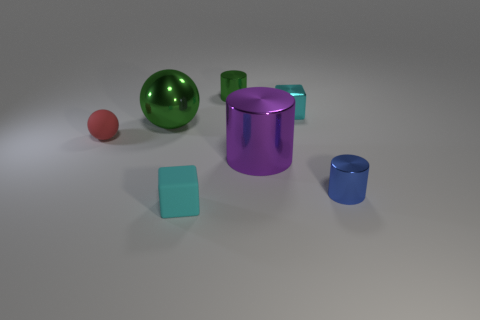Subtract all blue cylinders. How many cylinders are left? 2 Add 2 small yellow matte balls. How many objects exist? 9 Subtract all blocks. How many objects are left? 5 Subtract all brown cylinders. Subtract all cyan spheres. How many cylinders are left? 3 Subtract all small green cubes. Subtract all large purple metallic objects. How many objects are left? 6 Add 6 green balls. How many green balls are left? 7 Add 1 small purple balls. How many small purple balls exist? 1 Subtract 0 gray cylinders. How many objects are left? 7 